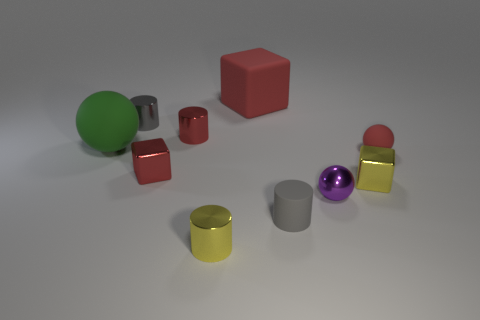What number of other things are the same color as the small matte cylinder?
Offer a terse response. 1. Is the red cylinder the same size as the gray metal object?
Make the answer very short. Yes. How many things are either red metal cubes or small red balls that are to the right of the tiny purple metallic ball?
Keep it short and to the point. 2. Is the number of red metal things that are on the right side of the big red block less than the number of tiny red blocks that are behind the tiny matte cylinder?
Offer a very short reply. Yes. How many other things are there of the same material as the green object?
Give a very brief answer. 3. There is a matte thing that is right of the gray rubber cylinder; does it have the same color as the big cube?
Keep it short and to the point. Yes. There is a red metal object behind the tiny red rubber ball; are there any small things that are to the left of it?
Offer a very short reply. Yes. There is a tiny object that is both left of the purple metallic ball and to the right of the tiny yellow cylinder; what material is it?
Your answer should be very brief. Rubber. There is a large thing that is made of the same material as the large red cube; what is its shape?
Provide a short and direct response. Sphere. Are the gray thing that is on the left side of the small yellow cylinder and the purple thing made of the same material?
Your answer should be compact. Yes. 